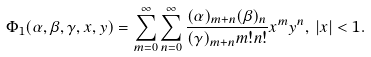<formula> <loc_0><loc_0><loc_500><loc_500>\Phi _ { 1 } ( \alpha , \beta , \gamma , x , y ) = \sum _ { m = 0 } ^ { \infty } \sum _ { n = 0 } ^ { \infty } \frac { ( \alpha ) _ { m + n } ( \beta ) _ { n } } { ( \gamma ) _ { m + n } m ! n ! } x ^ { m } y ^ { n } , \, | x | < 1 .</formula> 